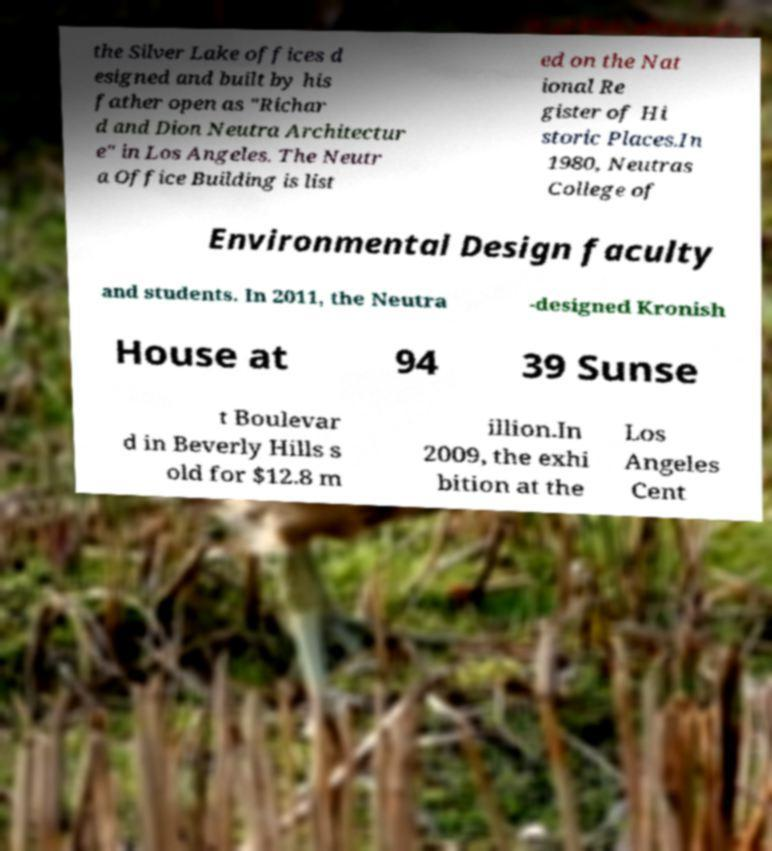Could you assist in decoding the text presented in this image and type it out clearly? the Silver Lake offices d esigned and built by his father open as "Richar d and Dion Neutra Architectur e" in Los Angeles. The Neutr a Office Building is list ed on the Nat ional Re gister of Hi storic Places.In 1980, Neutras College of Environmental Design faculty and students. In 2011, the Neutra -designed Kronish House at 94 39 Sunse t Boulevar d in Beverly Hills s old for $12.8 m illion.In 2009, the exhi bition at the Los Angeles Cent 